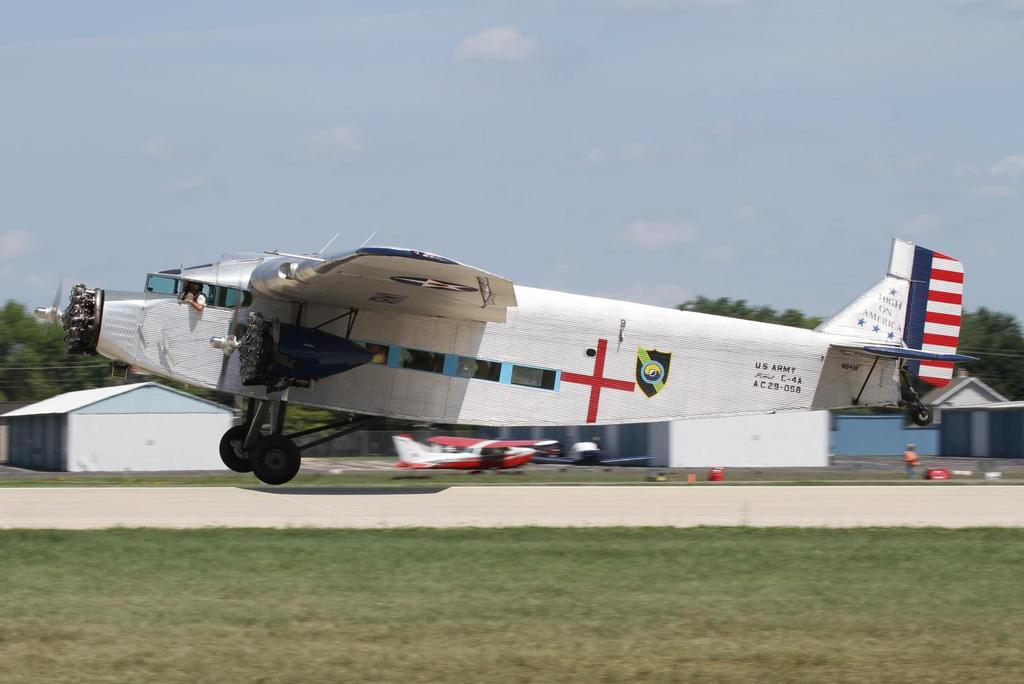<image>
Describe the image concisely. US Army C-4A, AC29-058 is the flight number shown on the side of this old plane. 